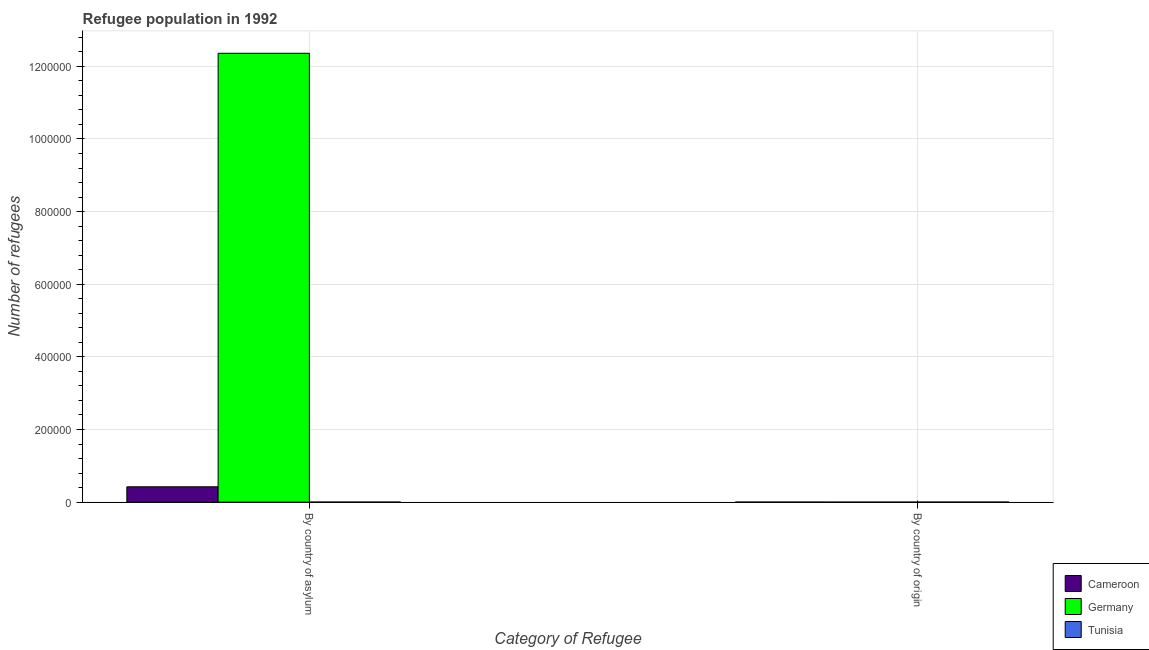How many different coloured bars are there?
Make the answer very short. 3. How many groups of bars are there?
Ensure brevity in your answer.  2. How many bars are there on the 1st tick from the right?
Your response must be concise. 3. What is the label of the 2nd group of bars from the left?
Ensure brevity in your answer.  By country of origin. What is the number of refugees by country of origin in Germany?
Give a very brief answer. 4. Across all countries, what is the maximum number of refugees by country of asylum?
Keep it short and to the point. 1.24e+06. Across all countries, what is the minimum number of refugees by country of origin?
Provide a short and direct response. 4. In which country was the number of refugees by country of origin maximum?
Provide a succinct answer. Tunisia. In which country was the number of refugees by country of asylum minimum?
Ensure brevity in your answer.  Tunisia. What is the total number of refugees by country of origin in the graph?
Keep it short and to the point. 173. What is the difference between the number of refugees by country of origin in Germany and that in Cameroon?
Provide a short and direct response. -79. What is the difference between the number of refugees by country of origin in Cameroon and the number of refugees by country of asylum in Tunisia?
Your answer should be compact. -28. What is the average number of refugees by country of origin per country?
Give a very brief answer. 57.67. What is the difference between the number of refugees by country of origin and number of refugees by country of asylum in Cameroon?
Make the answer very short. -4.22e+04. What is the ratio of the number of refugees by country of origin in Cameroon to that in Tunisia?
Offer a terse response. 0.97. Is the number of refugees by country of asylum in Cameroon less than that in Tunisia?
Provide a succinct answer. No. What does the 1st bar from the left in By country of asylum represents?
Make the answer very short. Cameroon. What does the 1st bar from the right in By country of origin represents?
Your response must be concise. Tunisia. How many countries are there in the graph?
Offer a terse response. 3. What is the difference between two consecutive major ticks on the Y-axis?
Give a very brief answer. 2.00e+05. Does the graph contain grids?
Your response must be concise. Yes. Where does the legend appear in the graph?
Make the answer very short. Bottom right. How many legend labels are there?
Give a very brief answer. 3. How are the legend labels stacked?
Provide a succinct answer. Vertical. What is the title of the graph?
Provide a short and direct response. Refugee population in 1992. What is the label or title of the X-axis?
Your answer should be compact. Category of Refugee. What is the label or title of the Y-axis?
Ensure brevity in your answer.  Number of refugees. What is the Number of refugees of Cameroon in By country of asylum?
Provide a succinct answer. 4.22e+04. What is the Number of refugees in Germany in By country of asylum?
Your response must be concise. 1.24e+06. What is the Number of refugees of Tunisia in By country of asylum?
Give a very brief answer. 111. Across all Category of Refugee, what is the maximum Number of refugees in Cameroon?
Offer a very short reply. 4.22e+04. Across all Category of Refugee, what is the maximum Number of refugees of Germany?
Give a very brief answer. 1.24e+06. Across all Category of Refugee, what is the maximum Number of refugees in Tunisia?
Provide a short and direct response. 111. Across all Category of Refugee, what is the minimum Number of refugees of Germany?
Offer a very short reply. 4. Across all Category of Refugee, what is the minimum Number of refugees in Tunisia?
Provide a succinct answer. 86. What is the total Number of refugees of Cameroon in the graph?
Make the answer very short. 4.23e+04. What is the total Number of refugees in Germany in the graph?
Provide a succinct answer. 1.24e+06. What is the total Number of refugees of Tunisia in the graph?
Offer a very short reply. 197. What is the difference between the Number of refugees of Cameroon in By country of asylum and that in By country of origin?
Your answer should be very brief. 4.22e+04. What is the difference between the Number of refugees of Germany in By country of asylum and that in By country of origin?
Your answer should be compact. 1.24e+06. What is the difference between the Number of refugees in Cameroon in By country of asylum and the Number of refugees in Germany in By country of origin?
Ensure brevity in your answer.  4.22e+04. What is the difference between the Number of refugees of Cameroon in By country of asylum and the Number of refugees of Tunisia in By country of origin?
Provide a succinct answer. 4.21e+04. What is the difference between the Number of refugees of Germany in By country of asylum and the Number of refugees of Tunisia in By country of origin?
Keep it short and to the point. 1.24e+06. What is the average Number of refugees of Cameroon per Category of Refugee?
Offer a very short reply. 2.12e+04. What is the average Number of refugees of Germany per Category of Refugee?
Offer a very short reply. 6.18e+05. What is the average Number of refugees of Tunisia per Category of Refugee?
Your response must be concise. 98.5. What is the difference between the Number of refugees of Cameroon and Number of refugees of Germany in By country of asylum?
Your answer should be compact. -1.19e+06. What is the difference between the Number of refugees of Cameroon and Number of refugees of Tunisia in By country of asylum?
Provide a succinct answer. 4.21e+04. What is the difference between the Number of refugees in Germany and Number of refugees in Tunisia in By country of asylum?
Provide a short and direct response. 1.24e+06. What is the difference between the Number of refugees of Cameroon and Number of refugees of Germany in By country of origin?
Offer a very short reply. 79. What is the difference between the Number of refugees of Germany and Number of refugees of Tunisia in By country of origin?
Provide a succinct answer. -82. What is the ratio of the Number of refugees in Cameroon in By country of asylum to that in By country of origin?
Give a very brief answer. 508.83. What is the ratio of the Number of refugees in Germany in By country of asylum to that in By country of origin?
Make the answer very short. 3.09e+05. What is the ratio of the Number of refugees in Tunisia in By country of asylum to that in By country of origin?
Your answer should be compact. 1.29. What is the difference between the highest and the second highest Number of refugees of Cameroon?
Your response must be concise. 4.22e+04. What is the difference between the highest and the second highest Number of refugees of Germany?
Provide a short and direct response. 1.24e+06. What is the difference between the highest and the second highest Number of refugees in Tunisia?
Make the answer very short. 25. What is the difference between the highest and the lowest Number of refugees of Cameroon?
Keep it short and to the point. 4.22e+04. What is the difference between the highest and the lowest Number of refugees in Germany?
Offer a very short reply. 1.24e+06. 